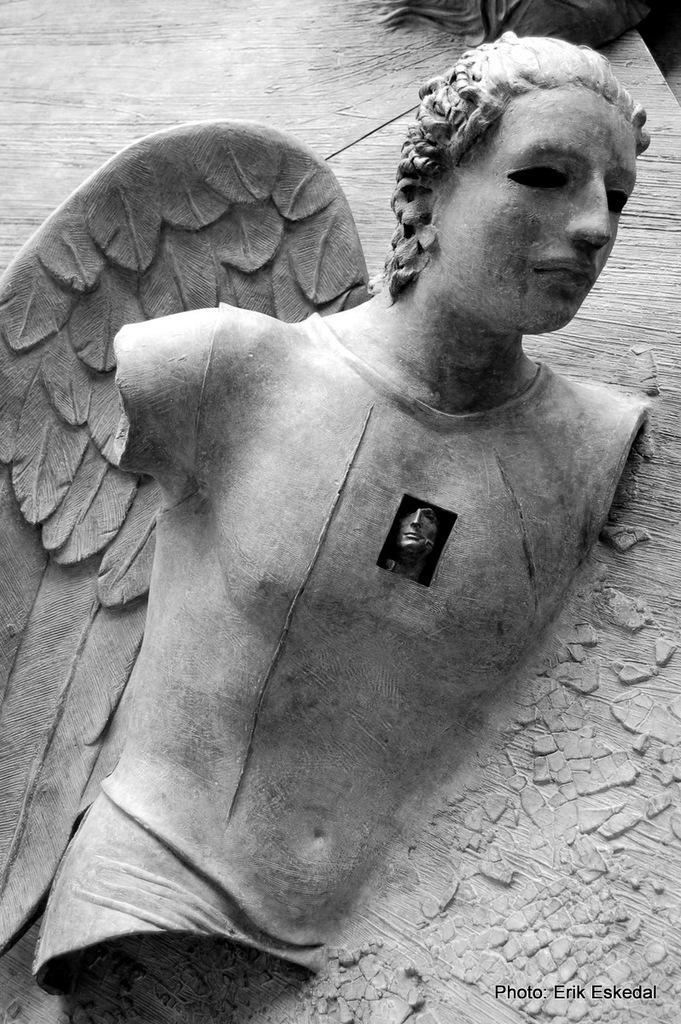In one or two sentences, can you explain what this image depicts? In this image I can see a sculpture in the front and I can see this image is black and white in colour. On the bottom right corner of this image I can see a watermark. 